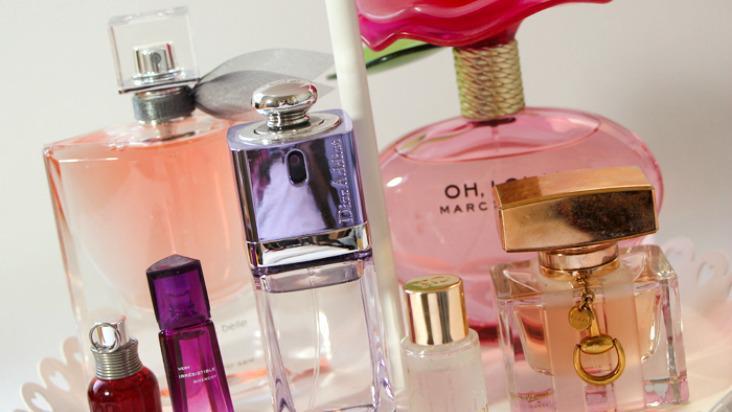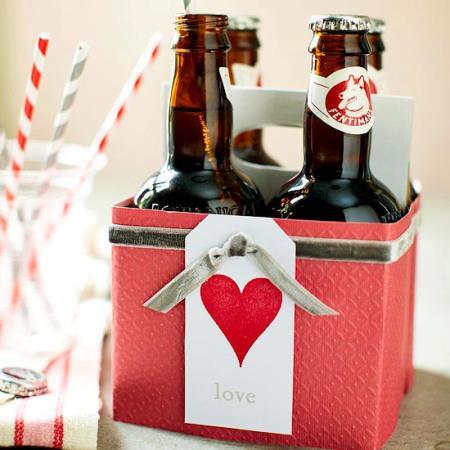The first image is the image on the left, the second image is the image on the right. For the images displayed, is the sentence "In one of the images, there is no lettering on any of the perfume bottles." factually correct? Answer yes or no. No. The first image is the image on the left, the second image is the image on the right. Given the left and right images, does the statement "One image contains eight fragrance bottles in various shapes and colors, including one purplish bottle topped with a rose shape." hold true? Answer yes or no. No. 